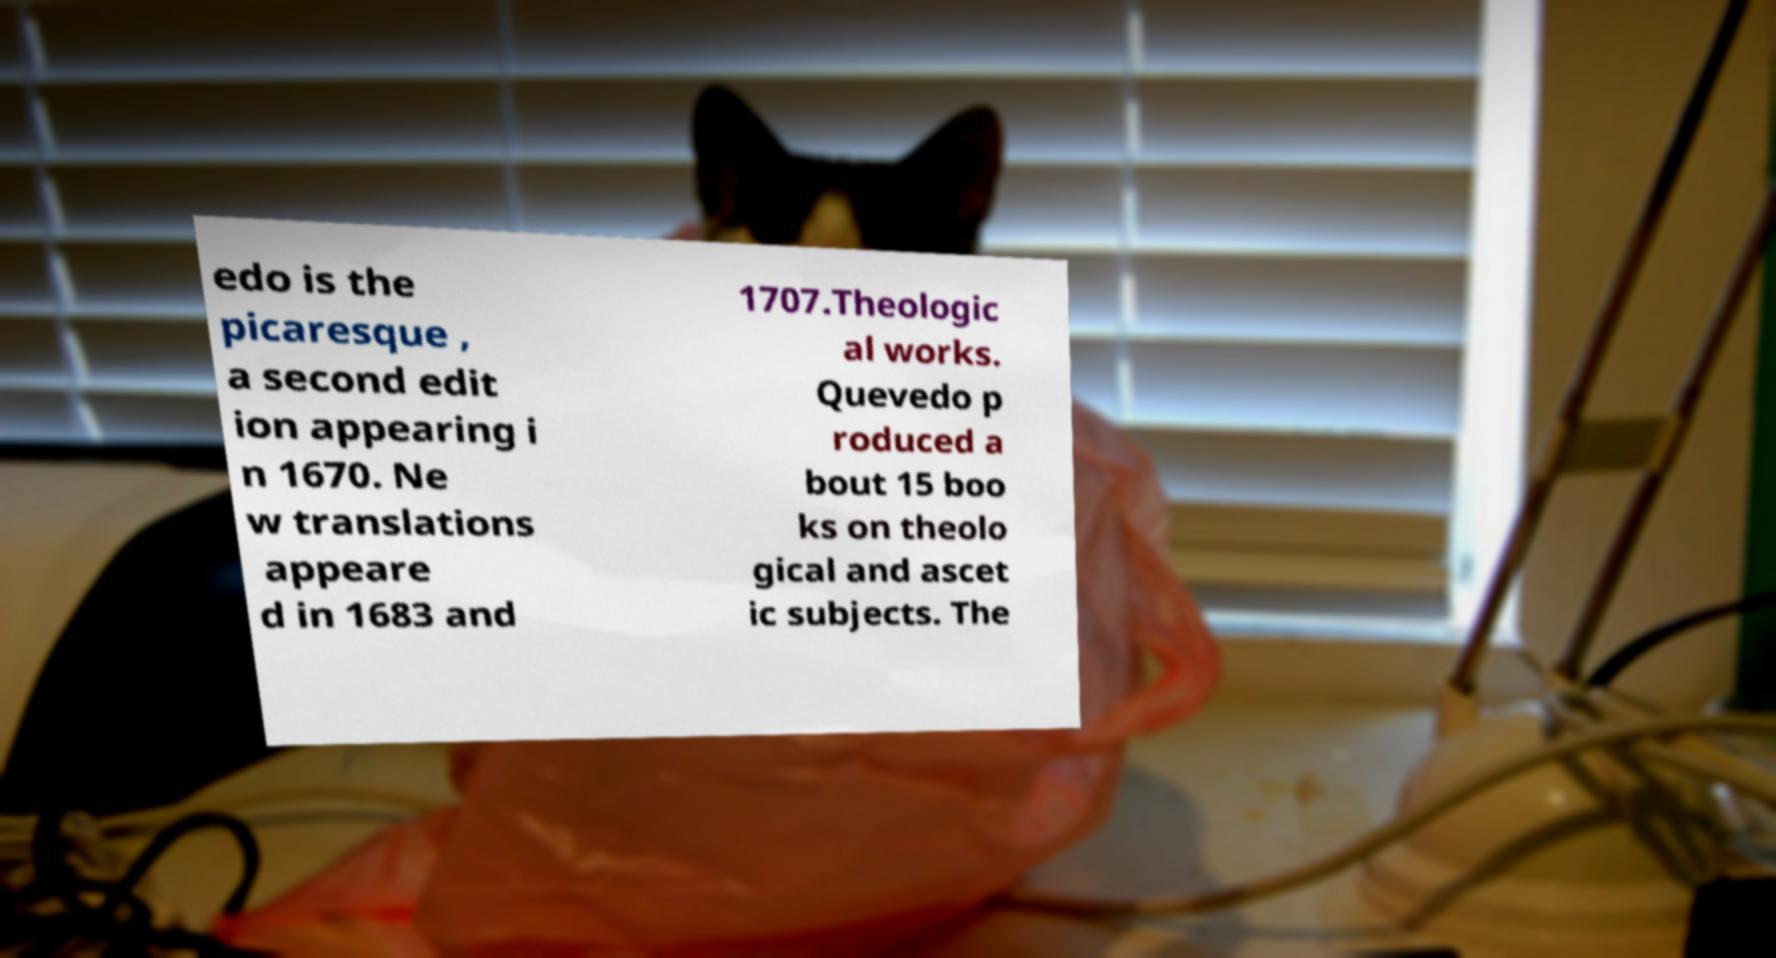Could you assist in decoding the text presented in this image and type it out clearly? edo is the picaresque , a second edit ion appearing i n 1670. Ne w translations appeare d in 1683 and 1707.Theologic al works. Quevedo p roduced a bout 15 boo ks on theolo gical and ascet ic subjects. The 